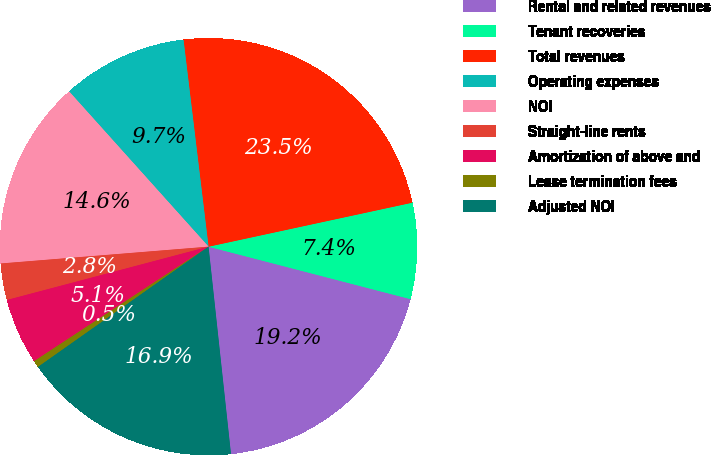Convert chart to OTSL. <chart><loc_0><loc_0><loc_500><loc_500><pie_chart><fcel>Rental and related revenues<fcel>Tenant recoveries<fcel>Total revenues<fcel>Operating expenses<fcel>NOI<fcel>Straight-line rents<fcel>Amortization of above and<fcel>Lease termination fees<fcel>Adjusted NOI<nl><fcel>19.24%<fcel>7.43%<fcel>23.53%<fcel>9.73%<fcel>14.64%<fcel>2.83%<fcel>5.13%<fcel>0.53%<fcel>16.94%<nl></chart> 